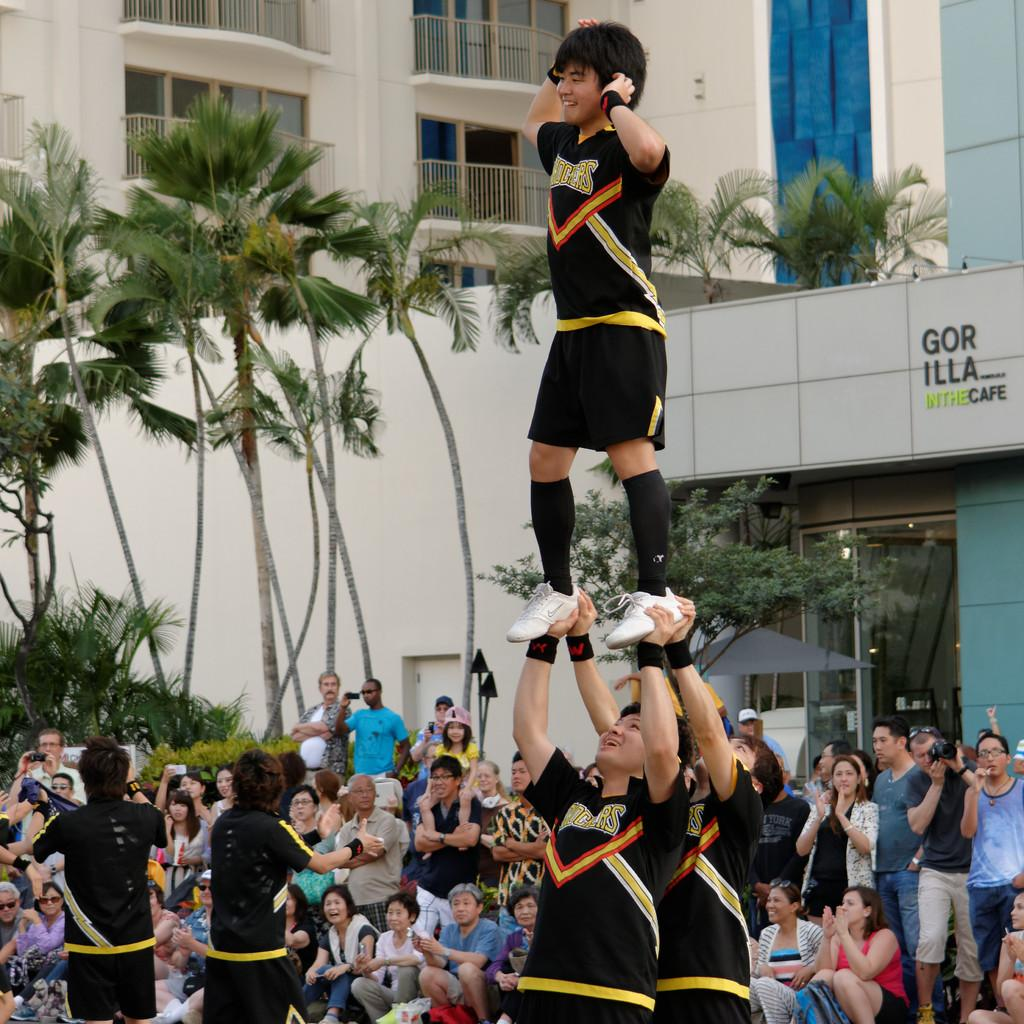Provide a one-sentence caption for the provided image. A pyramid of male Shockers cheerleaders performing in front of a crowd. 